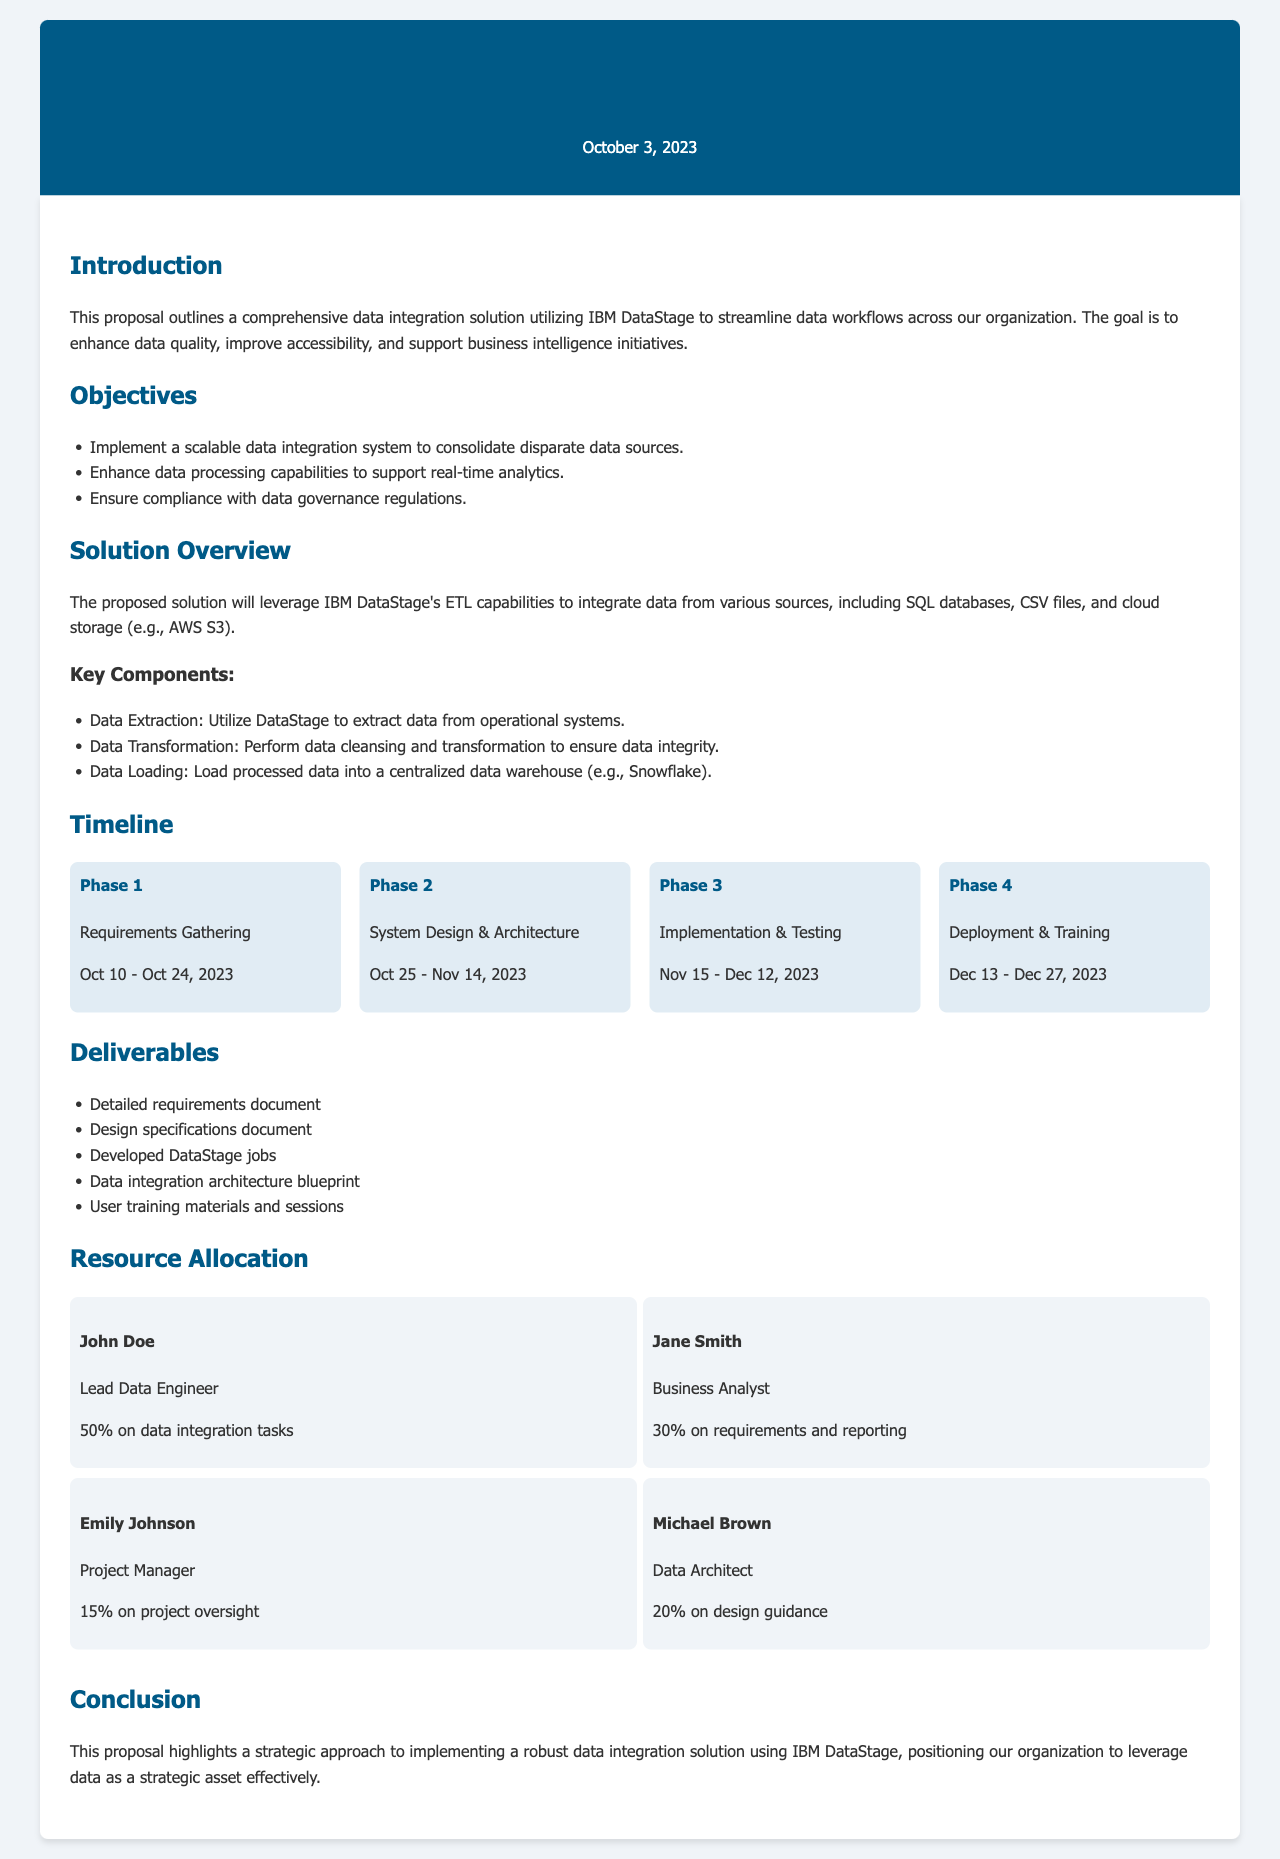What is the project title? The project title is stated at the beginning of the document as the name of the proposal.
Answer: Project Proposal for Data Integration Solution using IBM DataStage What are the dates for Phase 3? The timeline section specifies the dates for Phase 3: Implementation & Testing.
Answer: Nov 15 - Dec 12, 2023 Who is the Lead Data Engineer? The resource allocation section lists the team members and their roles.
Answer: John Doe What is the main objective regarding data processing? The objectives section outlines the goals, including a specific focus on data processing capabilities.
Answer: Enhance data processing capabilities to support real-time analytics How many deliverables are listed? The deliverables section enumerates the items that must be completed as part of the project.
Answer: Five What percentage of time is Michael Brown allocated to the project? The resource allocation section provides the percentage of time each resource will dedicate to the project tasks.
Answer: 20% What is the last date for deployment and training? The timeline section provides the schedule for final phases, including the end date for deployment and training.
Answer: Dec 27, 2023 What are the key components of the solution? The solution overview section describes what components are essential in the proposed integration solution.
Answer: Data Extraction, Data Transformation, Data Loading What is the project proposal date? The date is indicated at the top of the document to provide a reference for the proposal.
Answer: October 3, 2023 